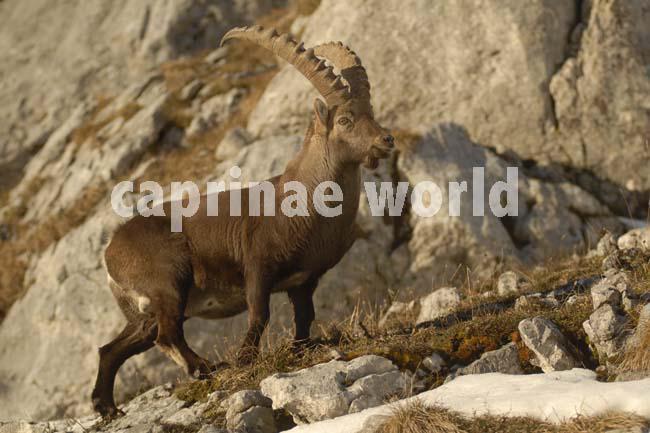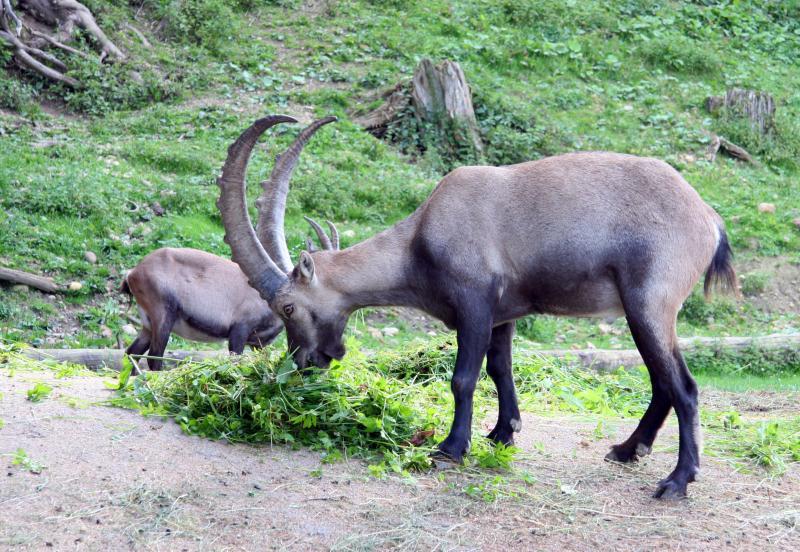The first image is the image on the left, the second image is the image on the right. Evaluate the accuracy of this statement regarding the images: "One animal with curved horns is laying on the ground and one animal is standing at the peak of something.". Is it true? Answer yes or no. No. 